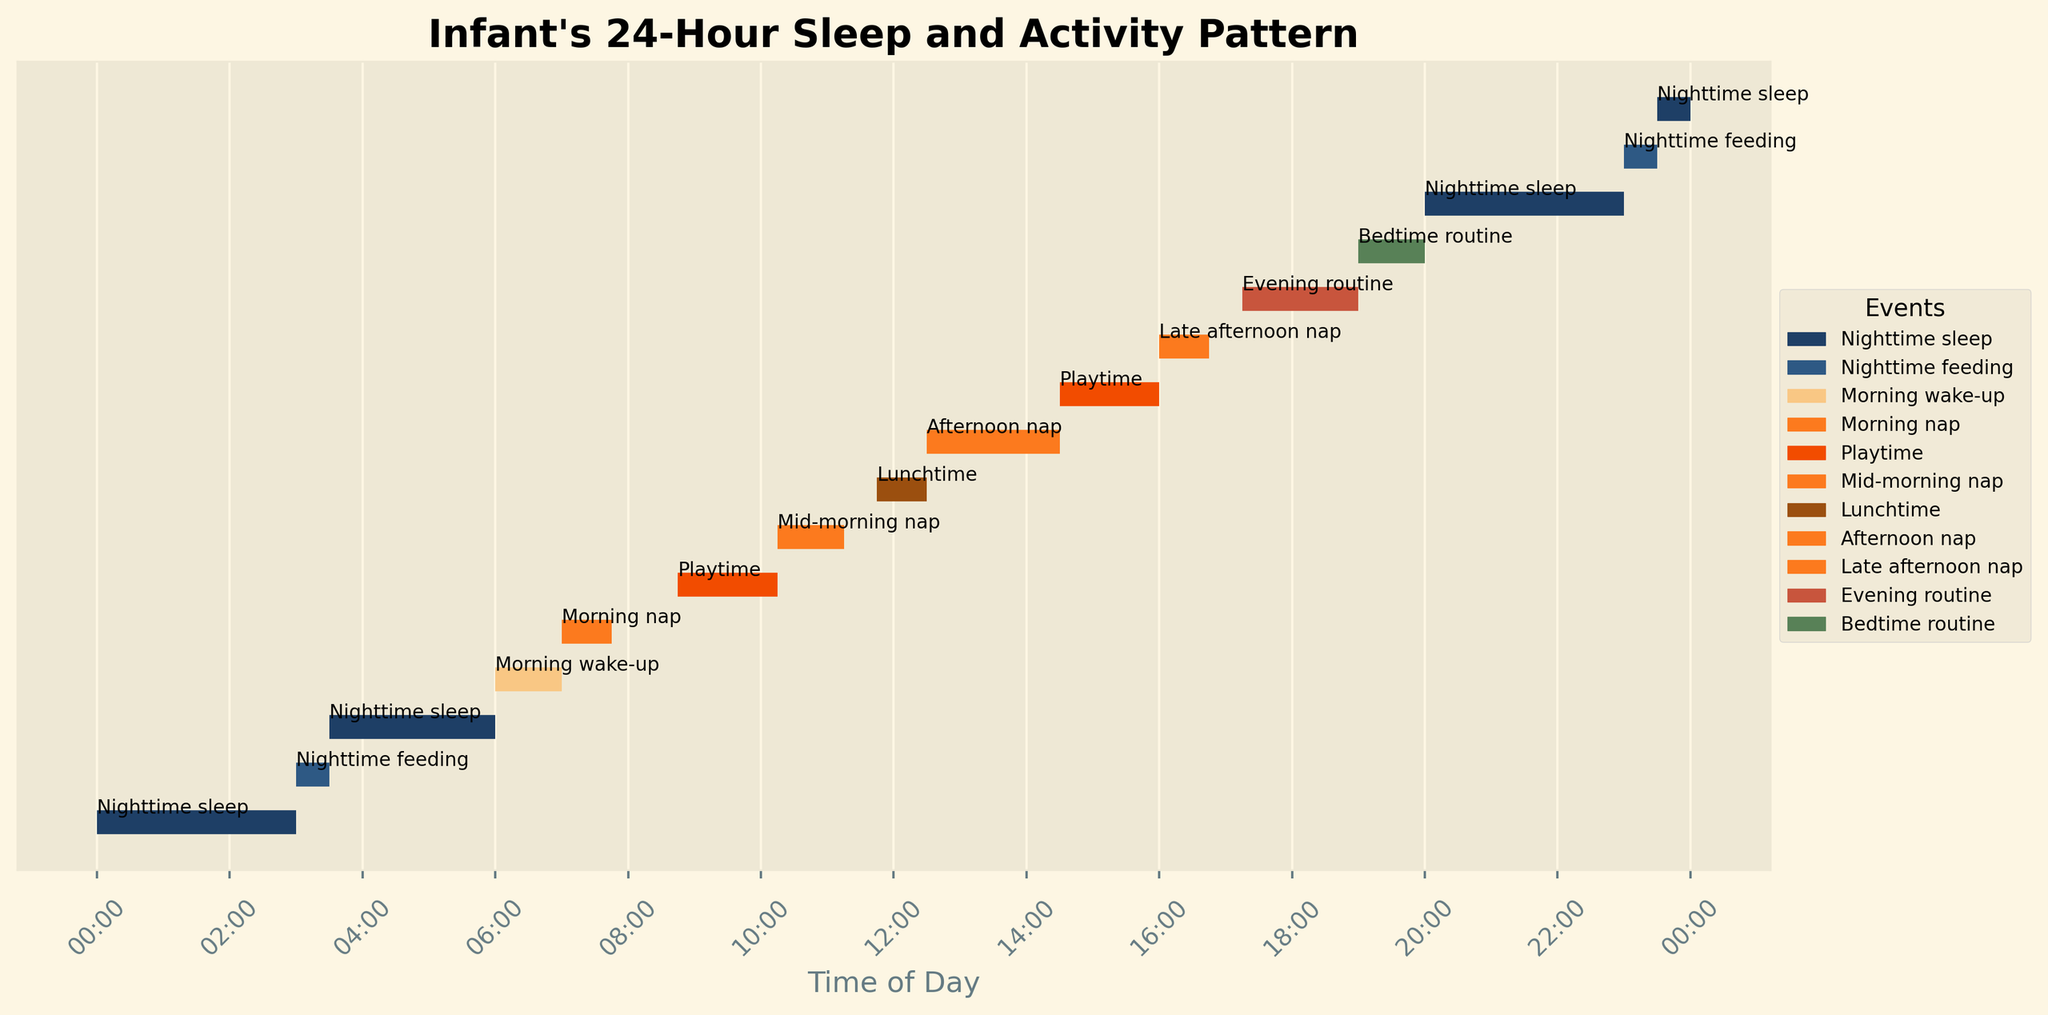What is the title of the figure? The title appears prominently at the top of the figure. It reads "Infant's 24-Hour Sleep and Activity Pattern"
Answer: Infant's 24-Hour Sleep and Activity Pattern What color is used to represent 'Morning nap'? The color used for 'Morning nap' is visible in the legend to the right of the figure. It is a shade of orange.
Answer: Orange How many times does the infant take a nap during the day? By looking at the events labeled with 'Morning nap', 'Mid-morning nap', 'Afternoon nap', and 'Late afternoon nap' in the y-axis of the event plot, four naps are visible.
Answer: 4 How long is the 'Nighttime sleep' from 00:00? The 'Nighttime sleep' starts at 00:00 and ends at 03:00. Referring to the information provided, this duration is 180 minutes.
Answer: 180 minutes What is the total duration of playtime throughout the day? To find the total playtime, sum the durations of all 'Playtime' events, which are 90 minutes at 08:45 and 90 minutes at 14:30. This results in 90 + 90 = 180 minutes.
Answer: 180 minutes During which time period does the infant have the longest continuous activity? The longest continuous activity can be determined by identifying the longest line segment, which is 'Afternoon nap' from 12:30 to 14:30, a duration of 120 minutes.
Answer: Afternoon nap Which event immediately follows the mid-morning nap? To find the event immediately following the mid-morning nap, look at the sequence of events. The mid-morning nap ends at 11:15, followed immediately by 'Lunchtime'.
Answer: Lunchtime What is the total duration of all nighttime sleep events combined? Sum the durations of all 'Nighttime sleep' segments: 180 minutes (00:00 to 03:00), 150 minutes (03:30 to 06:00), 180 minutes (20:00 to 23:00), and 30 minutes (23:30 to 00:00). This totals 180 + 150 + 180 + 30 = 540 minutes.
Answer: 540 minutes Compare the duration of the first 'Nighttime feeding' and 'Morning wake-up'. Which one is longer? 'Nighttime feeding' at 03:00 has a duration of 30 minutes, while 'Morning wake-up' at 06:00 lasts for 60 minutes. Morning wake-up is longer.
Answer: Morning wake-up When does the infant wake up after the first 'Nighttime sleep' segment, and what activity follows? The first 'Nighttime sleep' segment ends at 03:00, followed by 'Nighttime feeding' immediately.
Answer: Nighttime feeding 